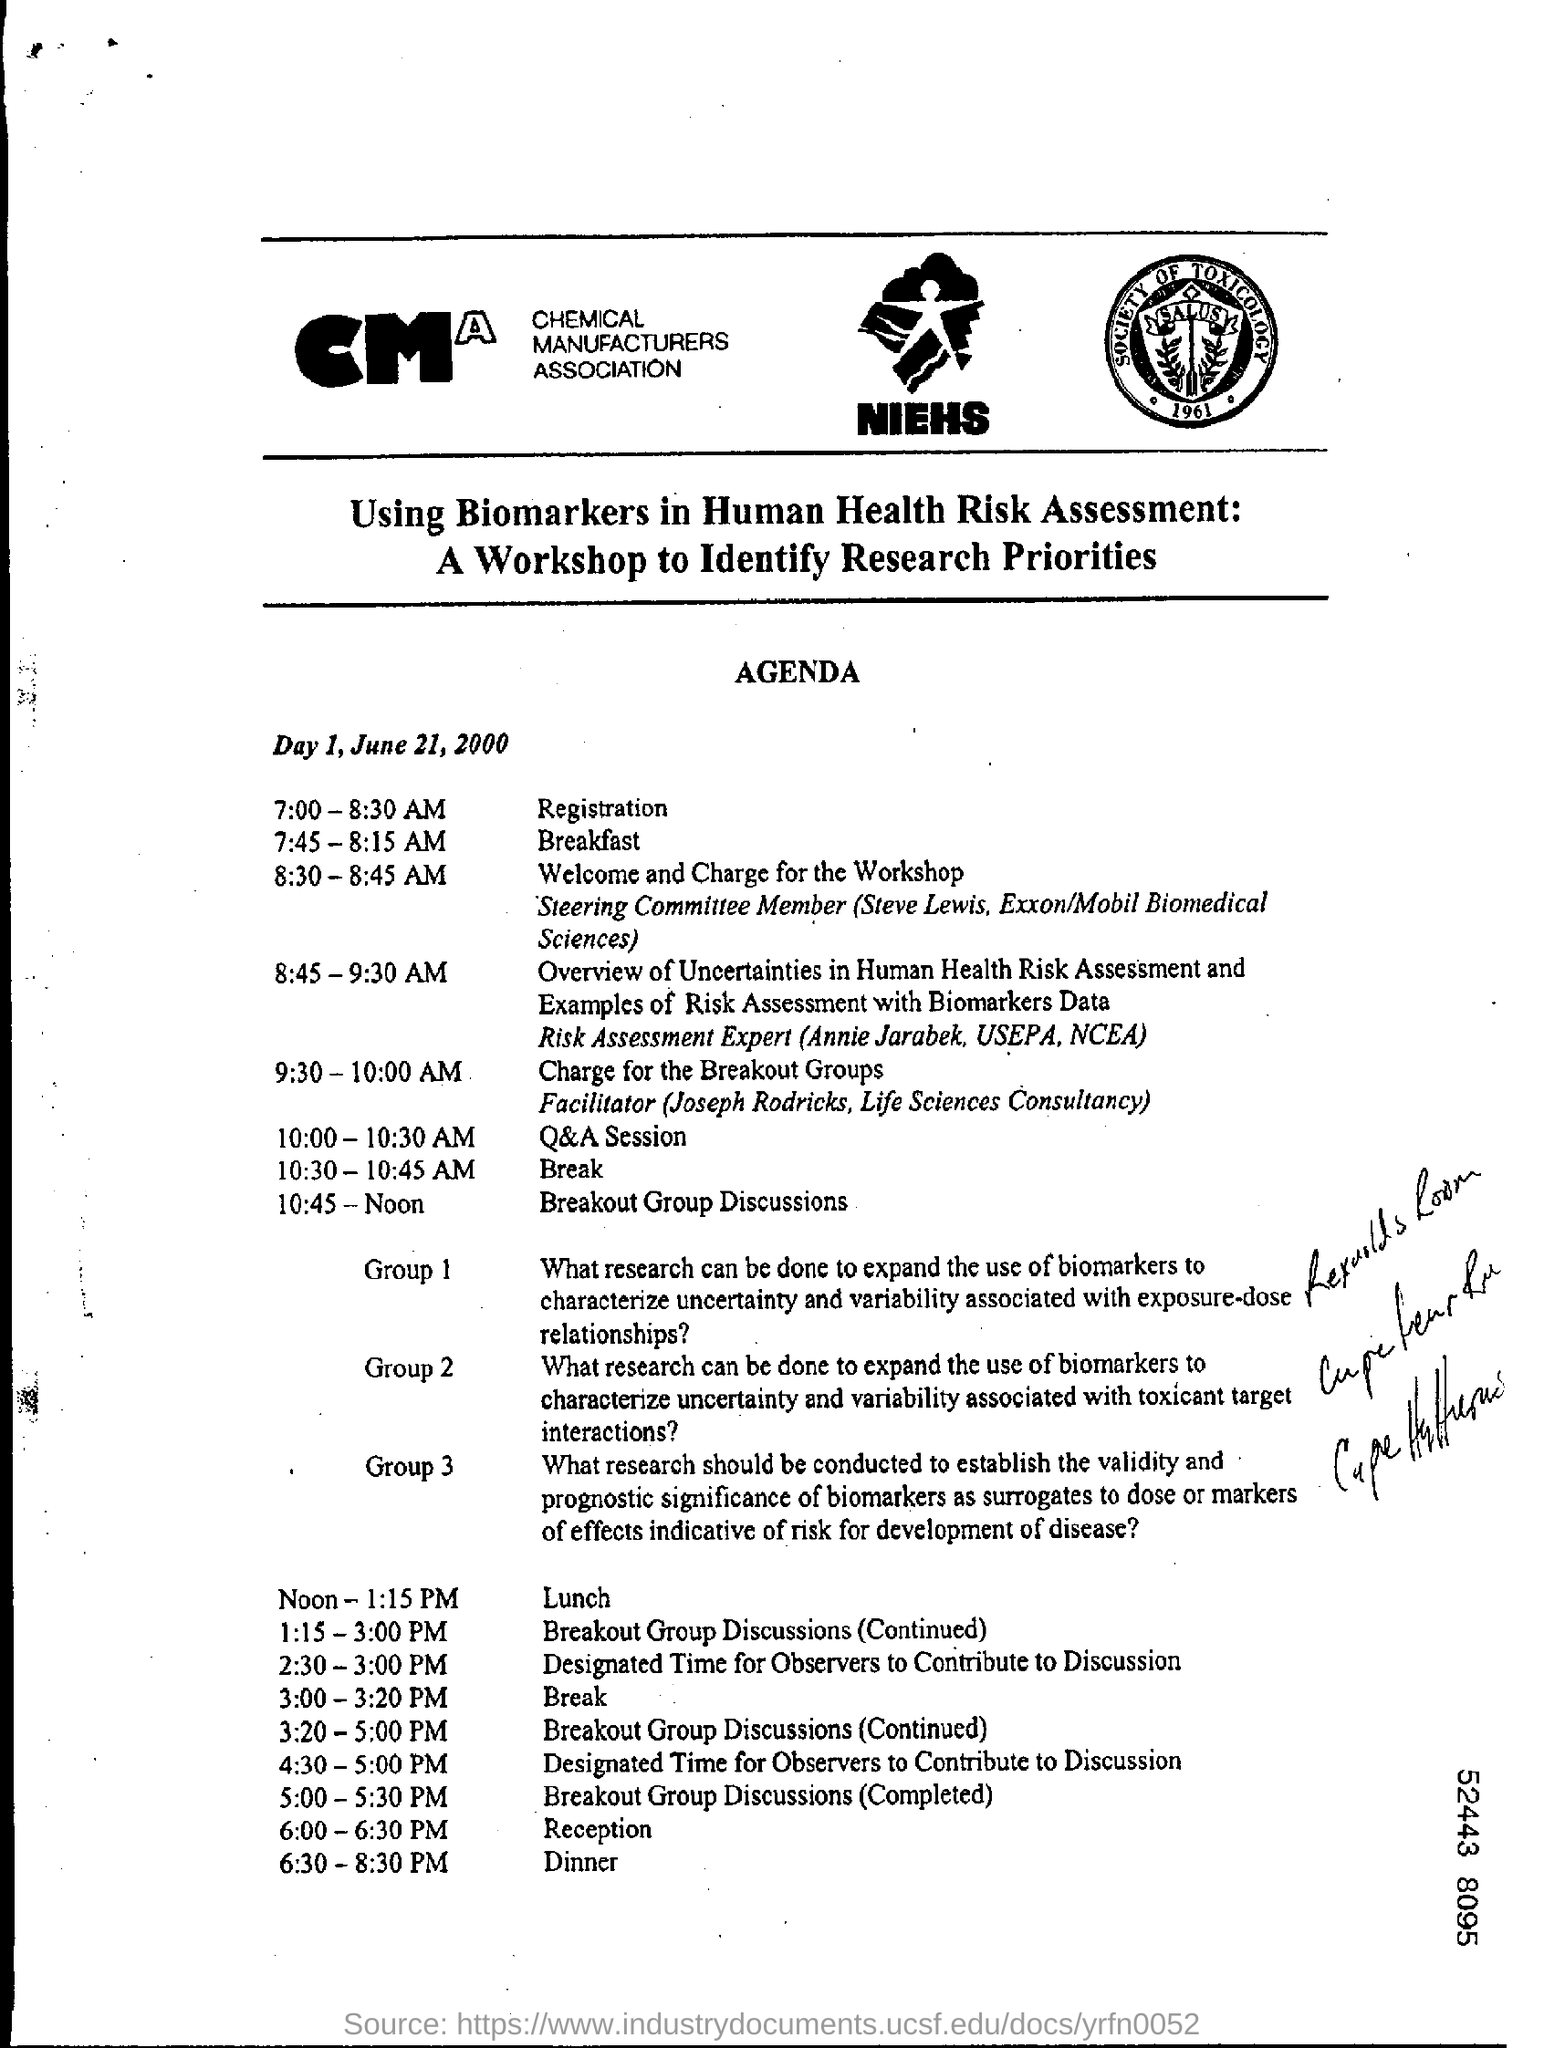Outline some significant characteristics in this image. What is the Time for Break? The time for break is from 10:30 to 10:45 AM. At 10:45 AM to Noon, the time has been scheduled for breakout group discussions. The time for dinner is 6:30 PM to 8:30 PM. The time for registration is from 7:00 to 8:30 AM. The time for the Q&A session is from 10:00 - 10:30 AM. 